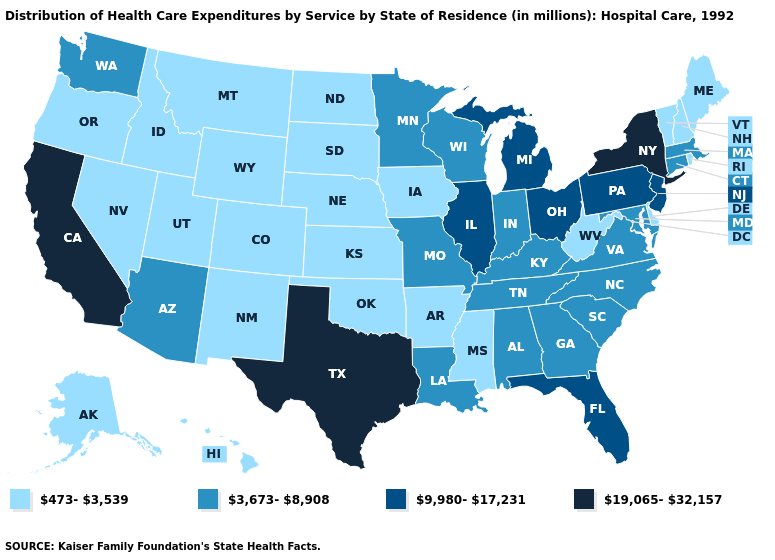Among the states that border Delaware , which have the highest value?
Concise answer only. New Jersey, Pennsylvania. Name the states that have a value in the range 473-3,539?
Give a very brief answer. Alaska, Arkansas, Colorado, Delaware, Hawaii, Idaho, Iowa, Kansas, Maine, Mississippi, Montana, Nebraska, Nevada, New Hampshire, New Mexico, North Dakota, Oklahoma, Oregon, Rhode Island, South Dakota, Utah, Vermont, West Virginia, Wyoming. Which states have the lowest value in the USA?
Be succinct. Alaska, Arkansas, Colorado, Delaware, Hawaii, Idaho, Iowa, Kansas, Maine, Mississippi, Montana, Nebraska, Nevada, New Hampshire, New Mexico, North Dakota, Oklahoma, Oregon, Rhode Island, South Dakota, Utah, Vermont, West Virginia, Wyoming. Does New York have the highest value in the Northeast?
Keep it brief. Yes. Does Kentucky have a lower value than Vermont?
Concise answer only. No. Name the states that have a value in the range 19,065-32,157?
Be succinct. California, New York, Texas. Name the states that have a value in the range 473-3,539?
Concise answer only. Alaska, Arkansas, Colorado, Delaware, Hawaii, Idaho, Iowa, Kansas, Maine, Mississippi, Montana, Nebraska, Nevada, New Hampshire, New Mexico, North Dakota, Oklahoma, Oregon, Rhode Island, South Dakota, Utah, Vermont, West Virginia, Wyoming. Is the legend a continuous bar?
Write a very short answer. No. What is the highest value in the West ?
Concise answer only. 19,065-32,157. Does the map have missing data?
Concise answer only. No. Name the states that have a value in the range 3,673-8,908?
Be succinct. Alabama, Arizona, Connecticut, Georgia, Indiana, Kentucky, Louisiana, Maryland, Massachusetts, Minnesota, Missouri, North Carolina, South Carolina, Tennessee, Virginia, Washington, Wisconsin. What is the value of North Dakota?
Quick response, please. 473-3,539. Name the states that have a value in the range 473-3,539?
Keep it brief. Alaska, Arkansas, Colorado, Delaware, Hawaii, Idaho, Iowa, Kansas, Maine, Mississippi, Montana, Nebraska, Nevada, New Hampshire, New Mexico, North Dakota, Oklahoma, Oregon, Rhode Island, South Dakota, Utah, Vermont, West Virginia, Wyoming. Which states have the lowest value in the MidWest?
Quick response, please. Iowa, Kansas, Nebraska, North Dakota, South Dakota. Among the states that border Arizona , which have the highest value?
Keep it brief. California. 